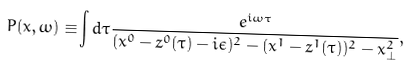<formula> <loc_0><loc_0><loc_500><loc_500>P ( x , \omega ) \equiv & \int d \tau \frac { e ^ { i \omega \tau } } { ( x ^ { 0 } - z ^ { 0 } ( \tau ) - i \epsilon ) ^ { 2 } - ( x ^ { 1 } - z ^ { 1 } ( \tau ) ) ^ { 2 } - x _ { \perp } ^ { 2 } } ,</formula> 